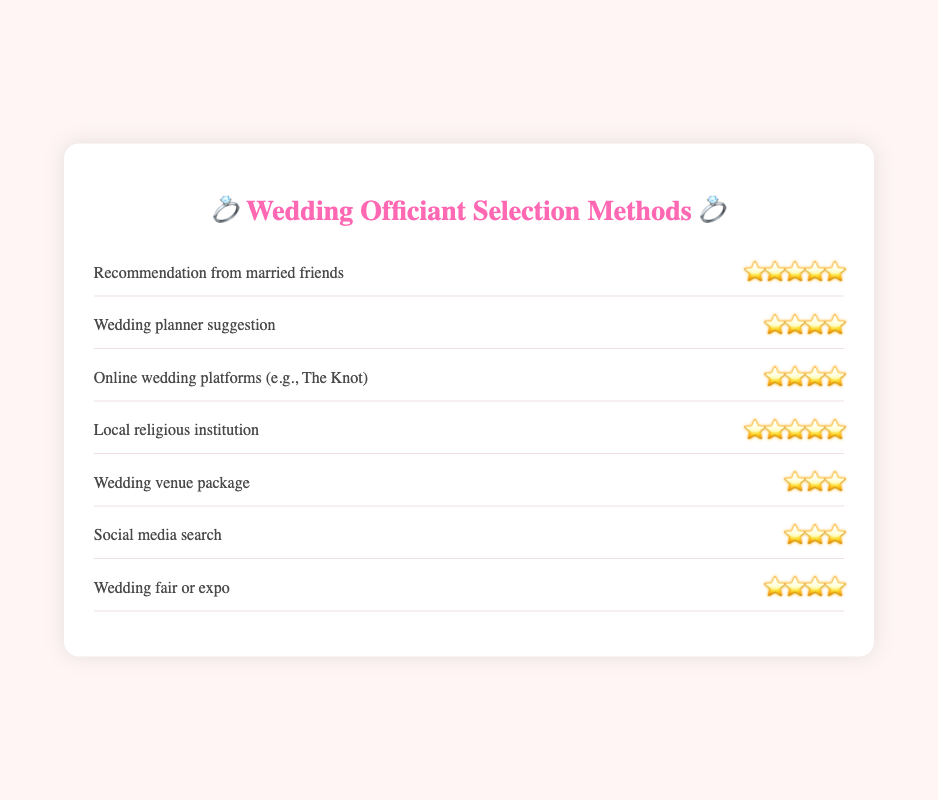Which method received the highest satisfaction rating? The highest rating value is denoted by five stars. Both "Recommendation from married friends" and "Local religious institution" have five stars.
Answer: Recommendation from married friends and Local religious institution Which method has the lowest satisfaction rating? The lowest rating value is denoted by three stars. Both "Wedding venue package" and "Social media search" have three stars.
Answer: Wedding venue package and Social media search How many methods received a rating of four stars or higher? We count the methods that have a rating of four stars or more: "Recommendation from married friends", "Wedding planner suggestion", "Online wedding platforms (e.g., The Knot)", "Local religious institution", and "Wedding fair or expo". This totals five methods.
Answer: 5 What is the rating for "Wedding planner suggestion"? Directly refer to the rating shown next to "Wedding planner suggestion," which is represented by four stars.
Answer: ⭐⭐⭐⭐ Which method has a higher satisfaction rating: "Wedding venue package" or "Wedding fair or expo"? By comparing the two ratings, "Wedding venue package" has three stars, whereas "Wedding fair or expo" has four stars. Hence, "Wedding fair or expo" has a higher rating.
Answer: Wedding fair or expo Do online wedding platforms like The Knot have a higher rating than social media search? Online wedding platforms (e.g., The Knot) have a rating of four stars, while social media search has a rating of three stars. Therefore, online wedding platforms have a higher rating.
Answer: Yes How many methods were evaluated based on their satisfaction ratings? Count the total number of methods listed in the chart. There are seven methods: "Recommendation from married friends", "Wedding planner suggestion", "Online wedding platforms (e.g., The Knot)", "Local religious institution", "Wedding venue package", "Social media search", and "Wedding fair or expo".
Answer: 7 Which method tied for the highest satisfaction rating with five stars? Both "Recommendation from married friends" and "Local religious institution" received five stars, thus tying for the highest rating.
Answer: Recommendation from married friends and Local religious institution What is the combined rating of "Wedding planner suggestion" and "Wedding venue package"? Sum the stars of both methods: "Wedding planner suggestion" (four stars) and "Wedding venue package" (three stars), resulting in a total of seven stars.
Answer: ⭐⭐⭐⭐⭐⭐⭐ 